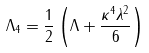Convert formula to latex. <formula><loc_0><loc_0><loc_500><loc_500>\Lambda _ { 4 } = \frac { 1 } { 2 } \left ( \Lambda + \frac { \kappa ^ { 4 } \lambda ^ { 2 } } { 6 } \right )</formula> 